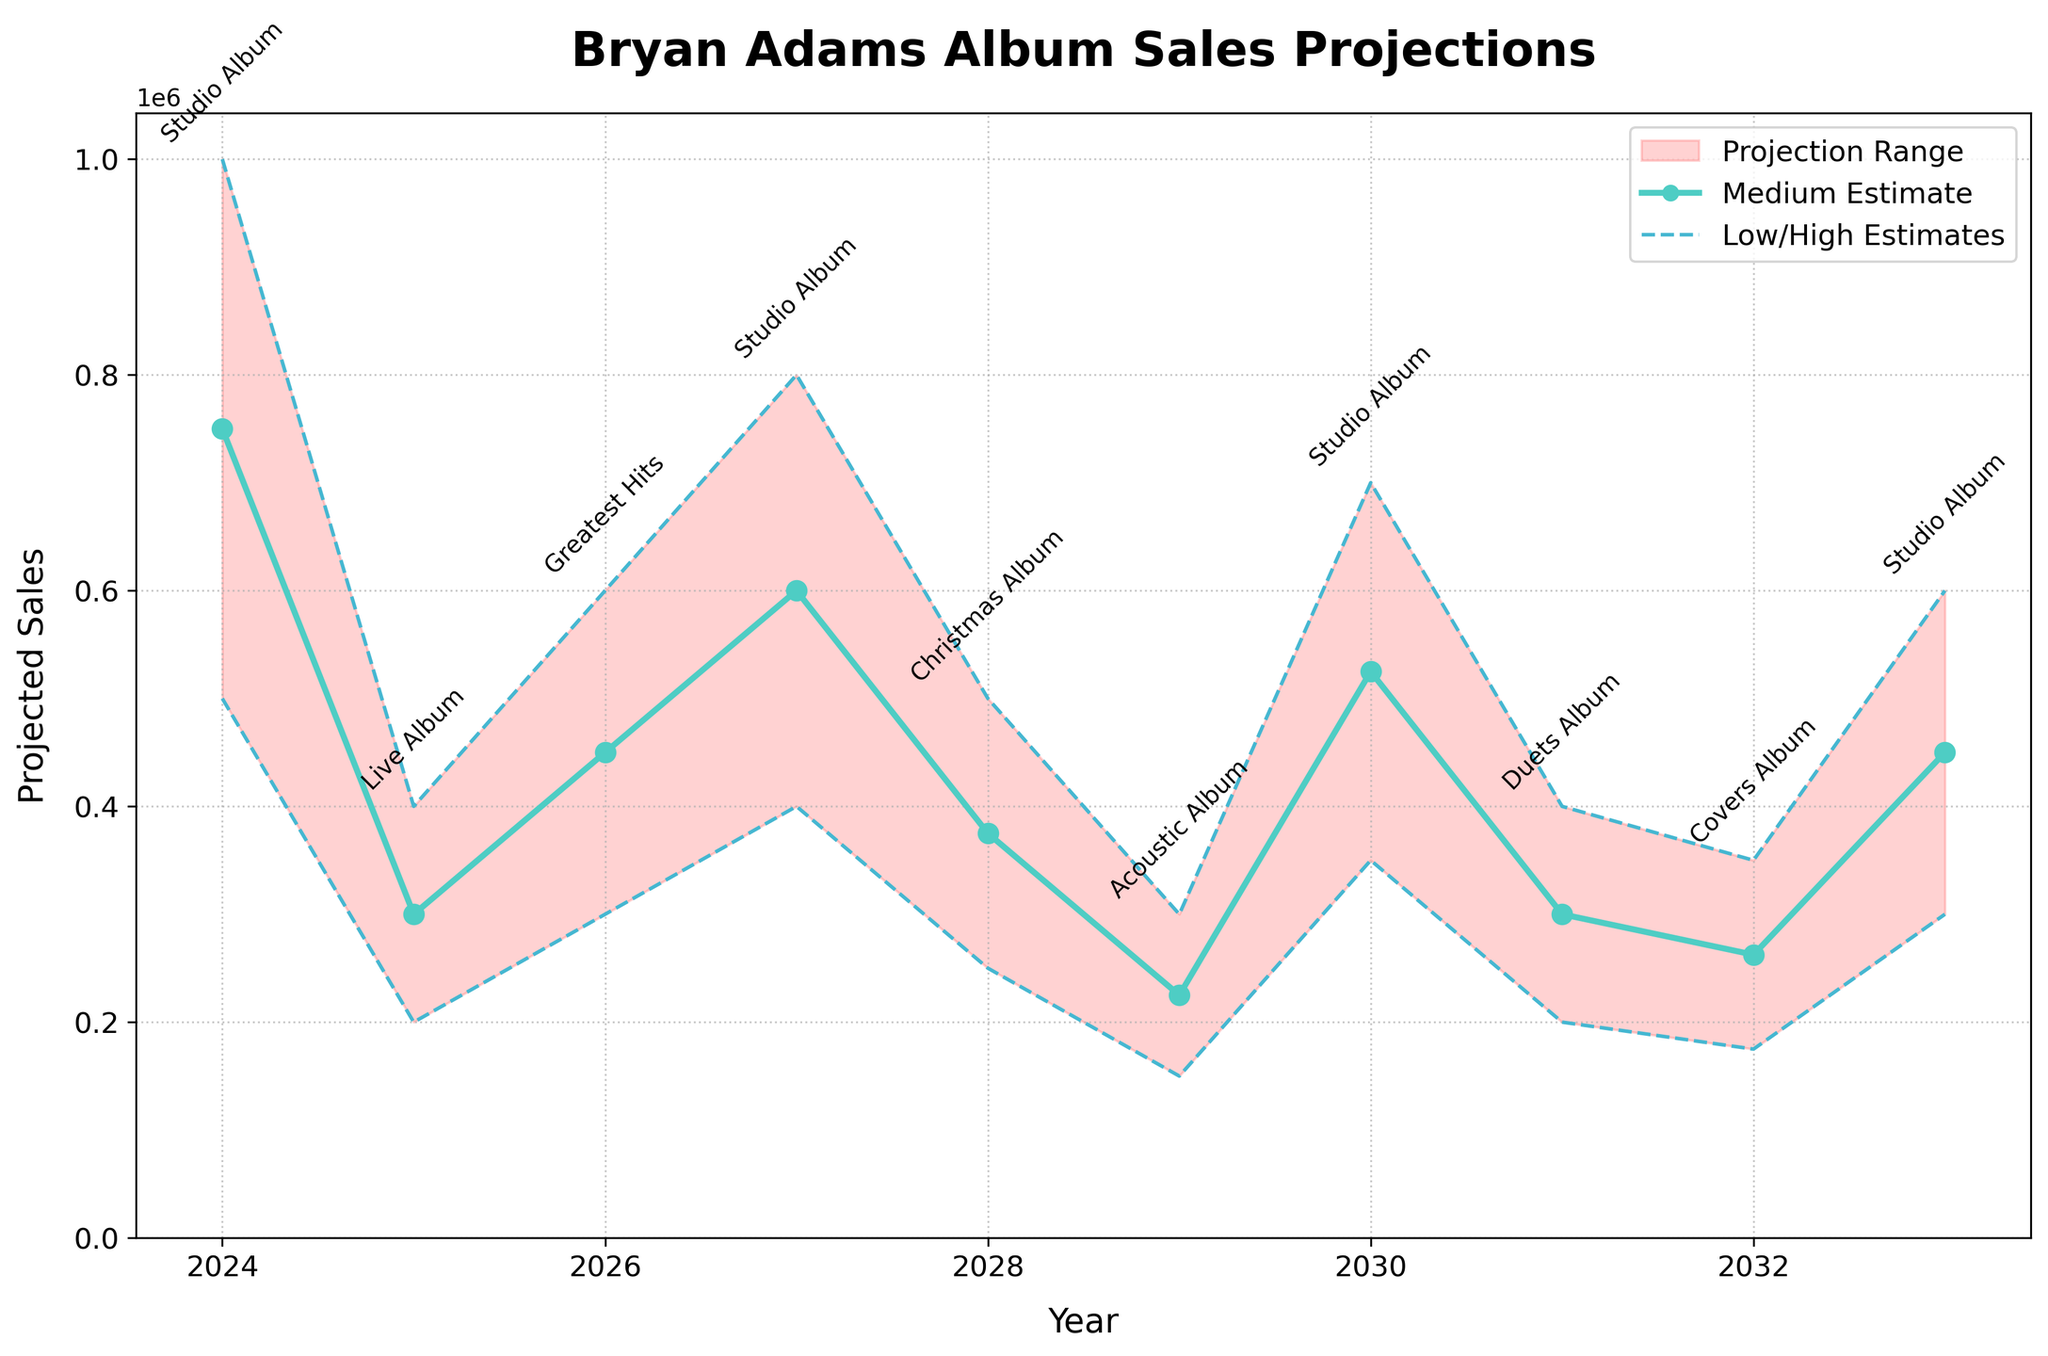What's the title of the chart? The title is located at the top of the chart and is displayed prominently. It reads "Bryan Adams Album Sales Projections."
Answer: Bryan Adams Album Sales Projections What is the projected low estimate for the Christmas album in 2028? By looking at the y-axis corresponding to the year 2028 and finding the low estimate value, we can see it's 250,000.
Answer: 250,000 How many different types of album releases does the chart project between 2024 and 2033? The album types are annotated next to the data points for each year. Counting these unique annotations, we have Studio Album, Live Album, Greatest Hits, Christmas Album, Acoustic Album, Duets Album, and Covers Album, which are 7 in total.
Answer: 7 In which year is the highest medium estimate projected, and what is it? The medium estimates for each year are plotted with a line. The highest point can be found in 2024 with a value of 750,000.
Answer: 2024, 750,000 What's the difference between the high and low estimates for the Studio Album in 2024? The high estimate for the Studio Album in 2024 is 1,000,000, and the low estimate is 500,000. The difference is calculated as 1,000,000 - 500,000.
Answer: 500,000 Which year has the lowest high estimate, and what is the album type for that year? Observing the highest estimates, the lowest high estimate occurs in 2029 for the Acoustic Album with a value of 300,000.
Answer: 2029, Acoustic Album How do the projected sales of Duets Album in 2031 compare to the projected sales of Live Album in 2025? The high estimates for Duets Album in 2031 is 400,000, and for Live Album in 2025 is also 400,000. Both are equal in terms of high estimates.
Answer: Equal If Bryan Adams were to release an album every year between 2024 and 2033, what is the average medium estimate per year? Adding all medium estimates from 2024 to 2033 (750,000 + 300,000 + 450,000 + 600,000 + 375,000 + 225,000 + 525,000 + 300,000 + 262,500 + 450,000) and dividing by the number of years (10) yields the average: (4,237,500/10).
Answer: 423,750 Of all the years listed, which projected album has the widest range between low and high estimates and what is that range? Comparing the ranges (high - low) for each year, the widest range is for Studio Album in 2024 with 1,000,000 - 500,000 = 500,000.
Answer: Studio Album, 500,000 